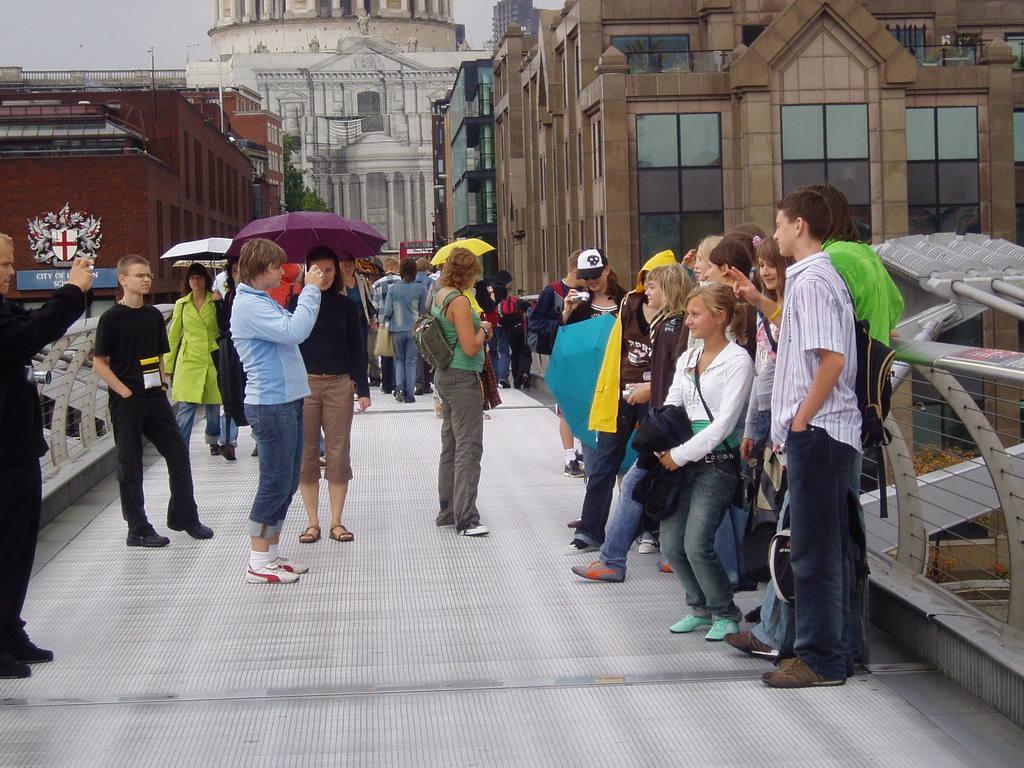In one or two sentences, can you explain what this image depicts? In this image, we can see a group of people are standing on the bridge. Few holding some objects and wearing bags. Background there are so many buildings, walls, glasses, trees and sky. 